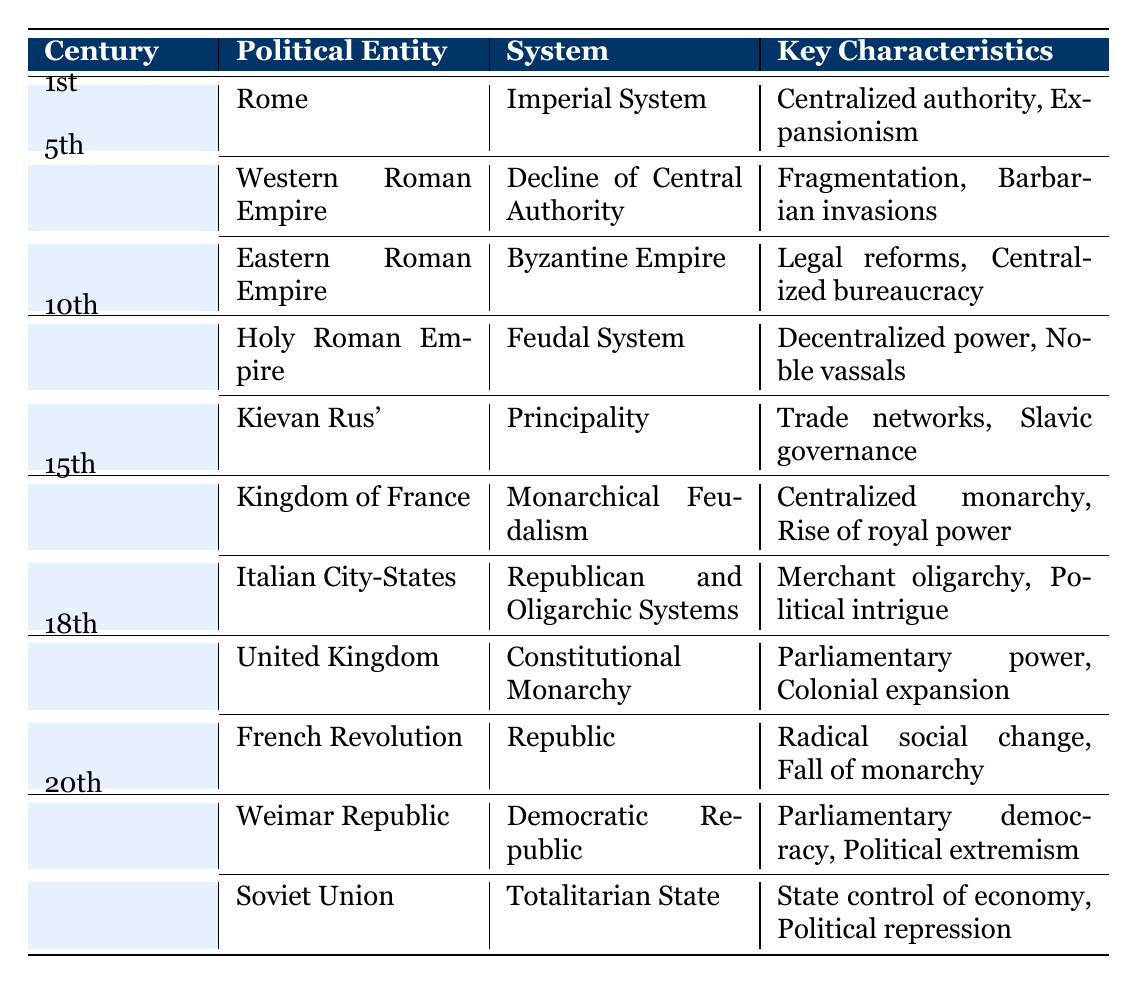What system of governance was present in the 1st Century in Rome? The table shows that Rome had an "Imperial System" during the 1st Century.
Answer: Imperial System Who were the key figures associated with the Byzantine Empire in the 5th Century? The table lists "Justinian I" and "Theodora" as key figures of the Byzantine Empire in the 5th Century.
Answer: Justinian I and Theodora Did the Holy Roman Empire in the 10th Century operate under a centralized authority? The table states that the Holy Roman Empire had a "Feudal System," indicating decentralized power, which contradicts centralized authority.
Answer: No Which political entity experienced a decline of central authority in the 5th Century? According to the table, the "Western Roman Empire" experienced a decline of central authority.
Answer: Western Roman Empire Which system had the key characteristic of "Radical social change"? The table associates "Radical social change" with the "Republic" system during the French Revolution in the 18th Century.
Answer: Republic How many political entities are listed for the 15th Century? The table lists two political entities for the 15th Century: "Kingdom of France" and "Italian City-States."
Answer: 2 What were the two characteristics of the Soviet Union in the 20th Century? The table specifies that the Soviet Union had "State control of economy" and "Political repression" as its key characteristics.
Answer: State control of economy and Political repression Which political entity transitioned from a monarchy to a republic in the 18th Century? The table indicates that the "French Revolution" moved from monarchy to republic, characterized by the fall of monarchy.
Answer: French Revolution What is the difference in governance systems between the 10th Century Holy Roman Empire and Kievan Rus'? The table lists the "Feudal System" for the Holy Roman Empire and "Principality" for Kievan Rus', indicating different governance structures.
Answer: Feudal System vs. Principality Identify the key figures from the 18th Century United Kingdom. The table lists "Queen Anne" and "George III" as the key figures from the United Kingdom in the 18th Century.
Answer: Queen Anne and George III 